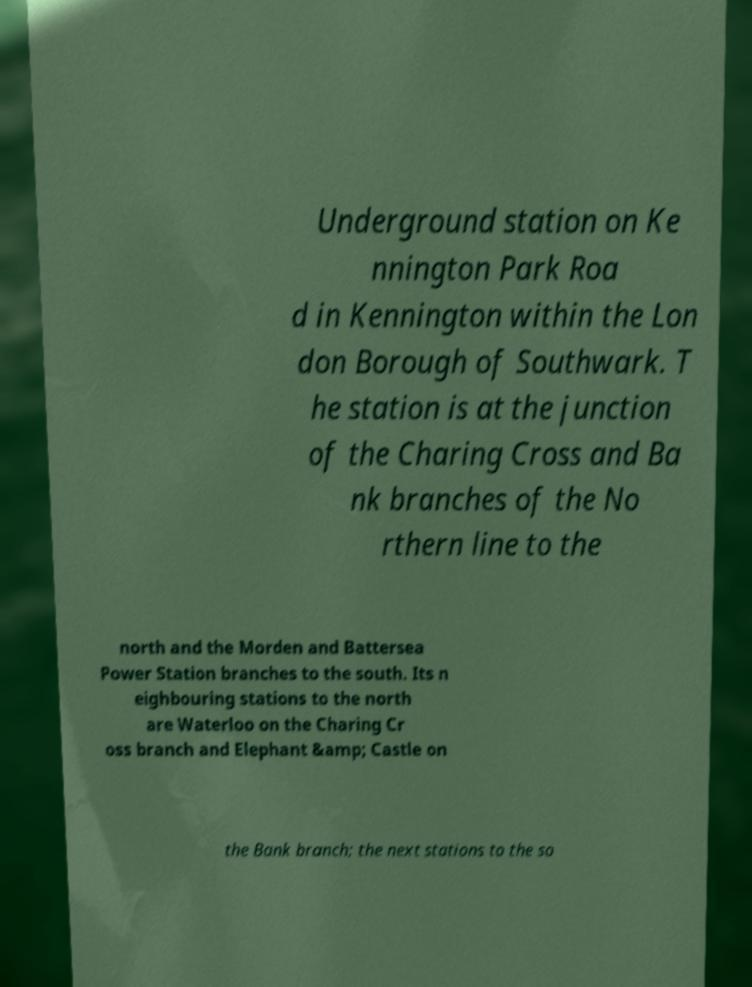Please read and relay the text visible in this image. What does it say? Underground station on Ke nnington Park Roa d in Kennington within the Lon don Borough of Southwark. T he station is at the junction of the Charing Cross and Ba nk branches of the No rthern line to the north and the Morden and Battersea Power Station branches to the south. Its n eighbouring stations to the north are Waterloo on the Charing Cr oss branch and Elephant &amp; Castle on the Bank branch; the next stations to the so 